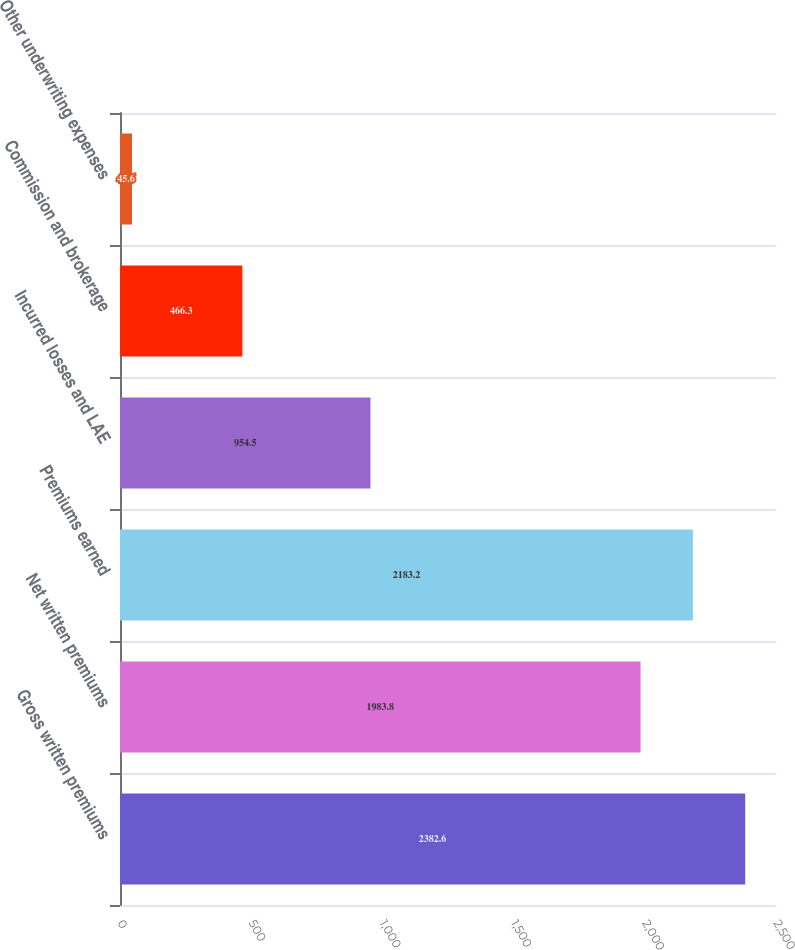Convert chart to OTSL. <chart><loc_0><loc_0><loc_500><loc_500><bar_chart><fcel>Gross written premiums<fcel>Net written premiums<fcel>Premiums earned<fcel>Incurred losses and LAE<fcel>Commission and brokerage<fcel>Other underwriting expenses<nl><fcel>2382.6<fcel>1983.8<fcel>2183.2<fcel>954.5<fcel>466.3<fcel>45.6<nl></chart> 